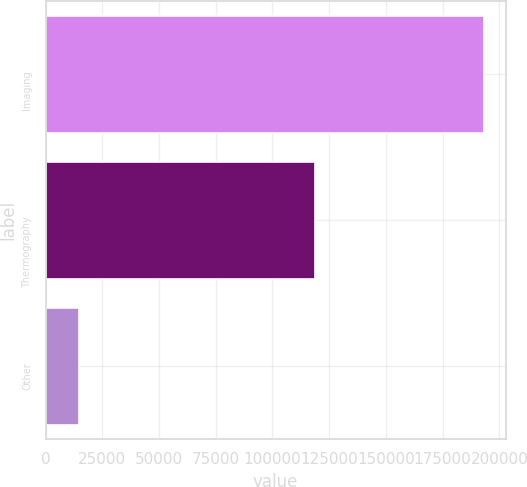<chart> <loc_0><loc_0><loc_500><loc_500><bar_chart><fcel>Imaging<fcel>Thermography<fcel>Other<nl><fcel>193132<fcel>118847<fcel>14886<nl></chart> 